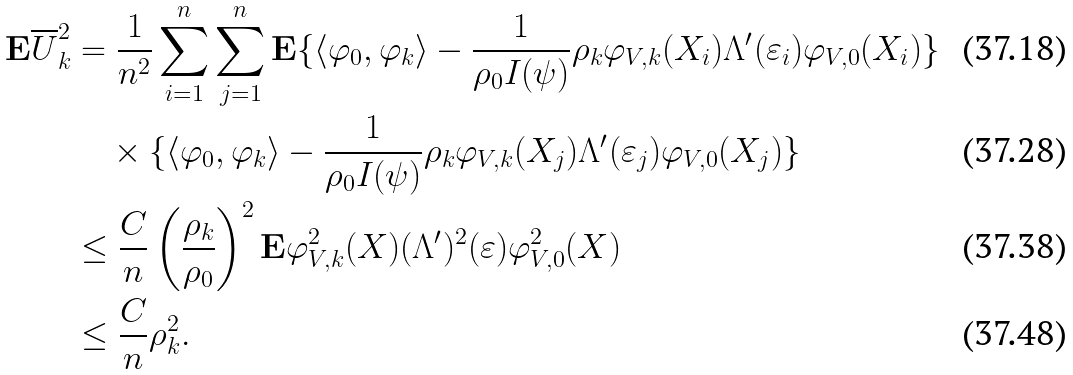Convert formula to latex. <formula><loc_0><loc_0><loc_500><loc_500>\mathbf E \overline { U } _ { k } ^ { 2 } & = \frac { 1 } { n ^ { 2 } } \sum _ { i = 1 } ^ { n } \sum _ { j = 1 } ^ { n } \mathbf E \{ \langle \varphi _ { 0 } , \varphi _ { k } \rangle - \frac { 1 } { \rho _ { 0 } I ( \psi ) } \rho _ { k } \varphi _ { V , k } ( X _ { i } ) \Lambda ^ { \prime } ( \varepsilon _ { i } ) \varphi _ { V , 0 } ( X _ { i } ) \} \\ & \quad \times \{ \langle \varphi _ { 0 } , \varphi _ { k } \rangle - \frac { 1 } { \rho _ { 0 } I ( \psi ) } \rho _ { k } \varphi _ { V , k } ( X _ { j } ) \Lambda ^ { \prime } ( \varepsilon _ { j } ) \varphi _ { V , 0 } ( X _ { j } ) \} \\ & \leq \frac { C } { n } \left ( \frac { \rho _ { k } } { \rho _ { 0 } } \right ) ^ { 2 } \mathbf E \varphi _ { V , k } ^ { 2 } ( X ) ( \Lambda ^ { \prime } ) ^ { 2 } ( \varepsilon ) \varphi _ { V , 0 } ^ { 2 } ( X ) \\ & \leq \frac { C } { n } \rho _ { k } ^ { 2 } .</formula> 